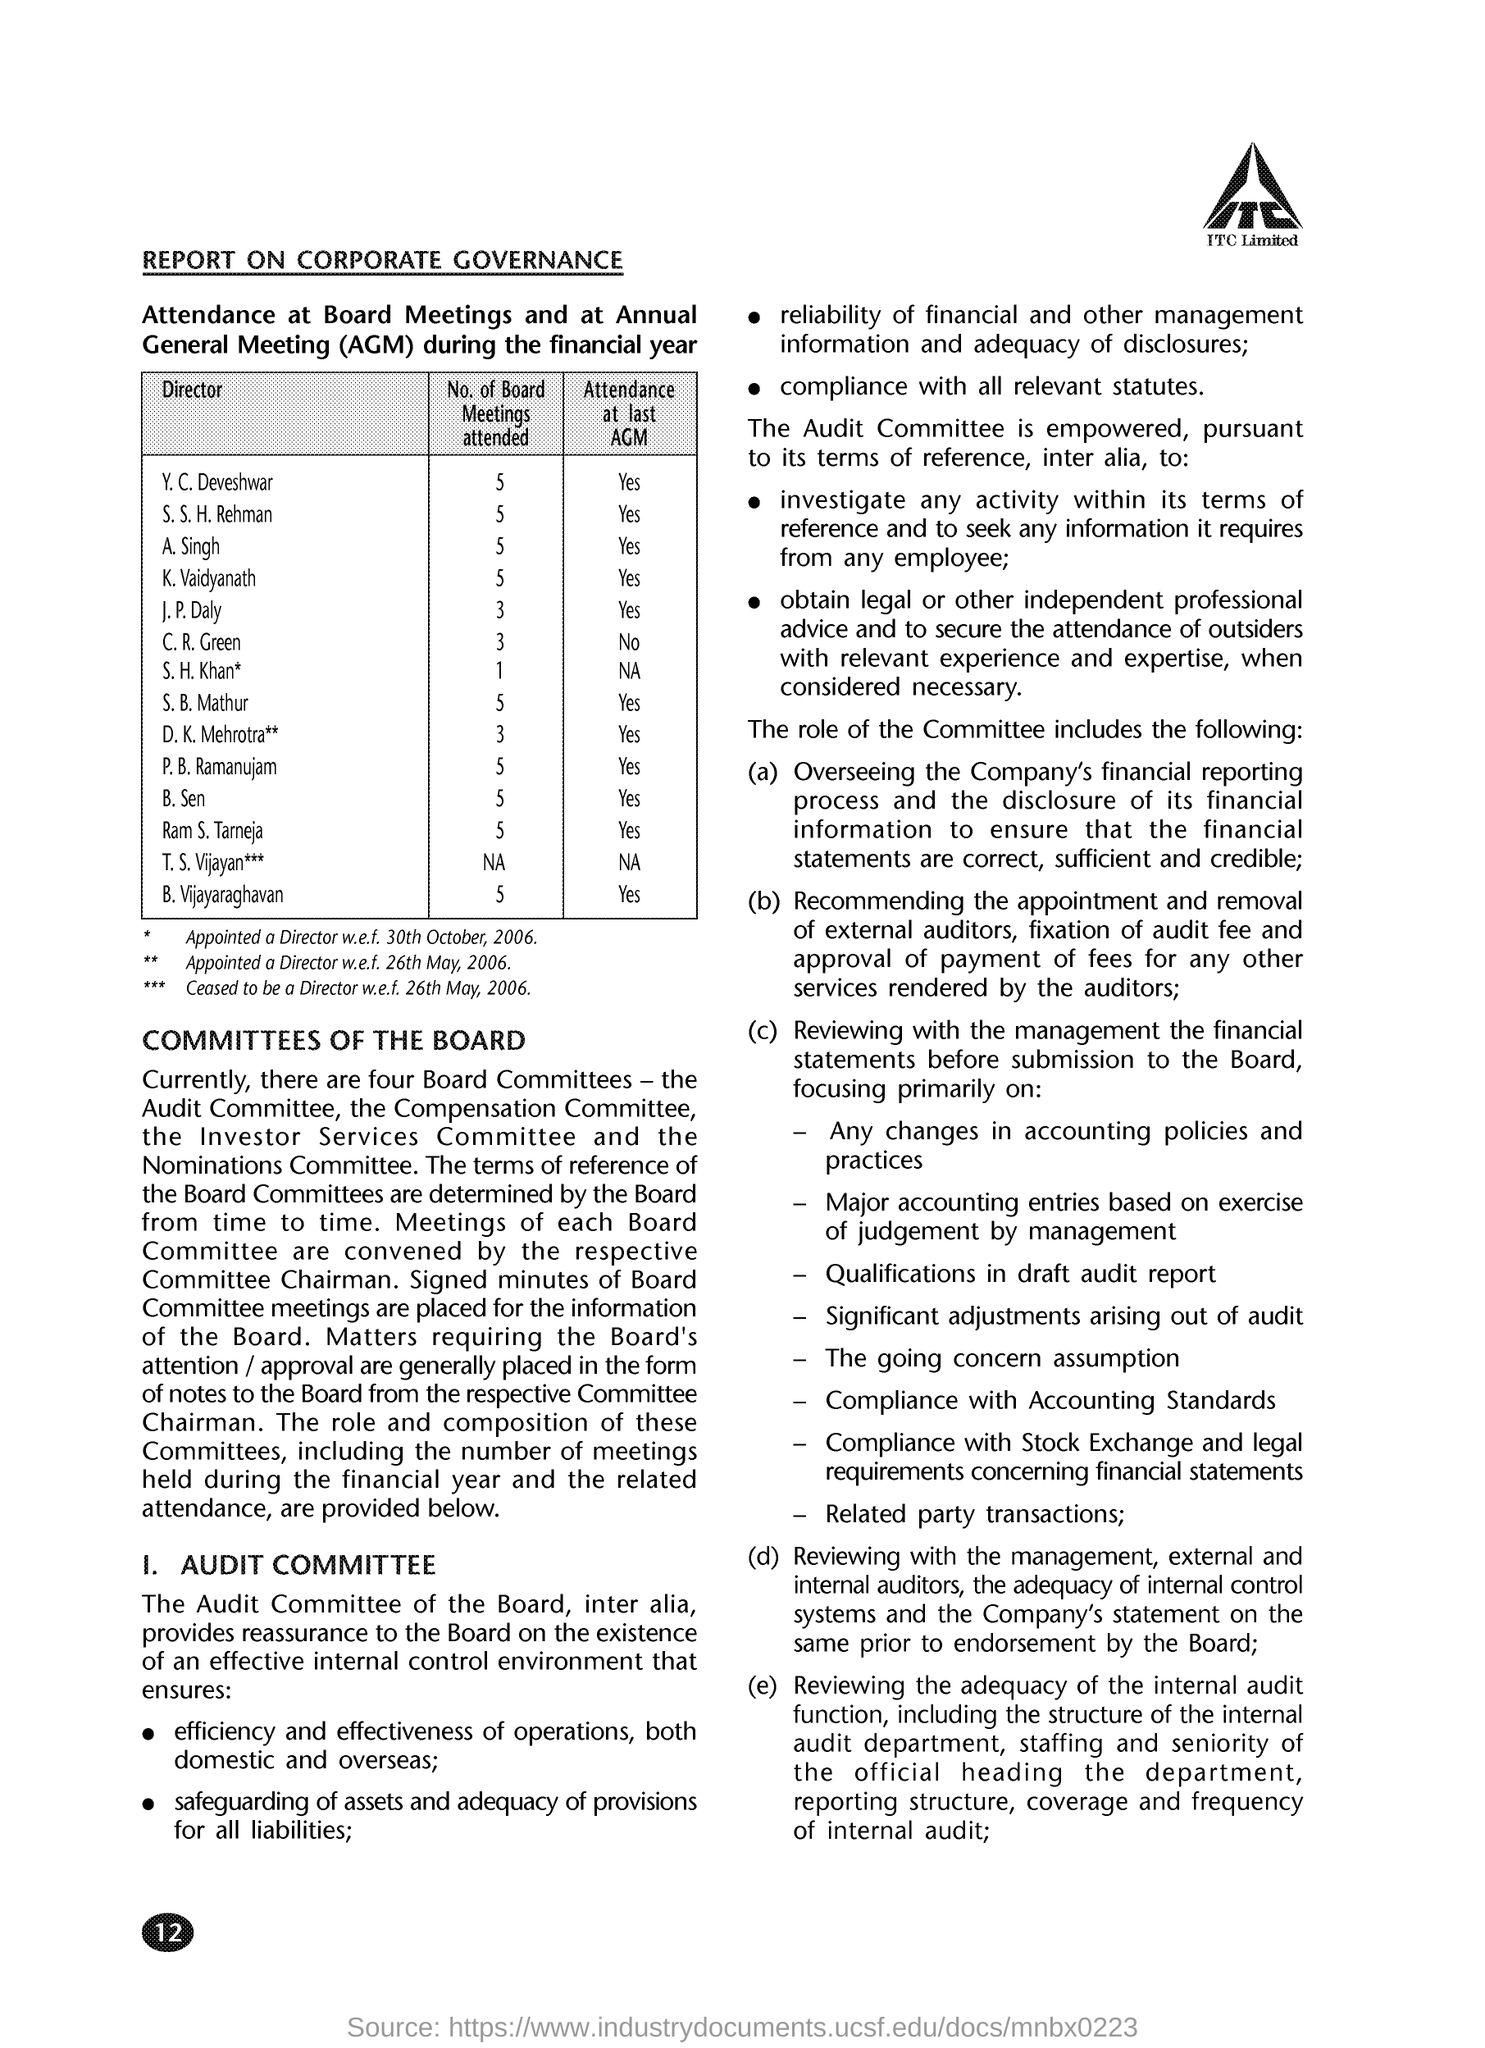Did Y. C. Deveshvar attend the last AGM?
Make the answer very short. Yes. What does AGM stand for?
Provide a succinct answer. Annual General Meeting. How many board meetings have S. B. Mathur attended?
Make the answer very short. 5. How many Board Committees are there currently?
Offer a terse response. Four. 